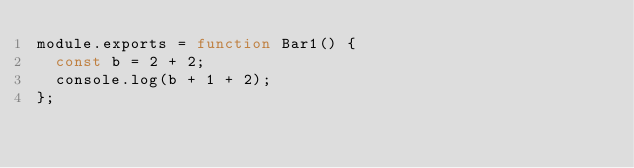<code> <loc_0><loc_0><loc_500><loc_500><_JavaScript_>module.exports = function Bar1() {
  const b = 2 + 2;
  console.log(b + 1 + 2);
};
</code> 